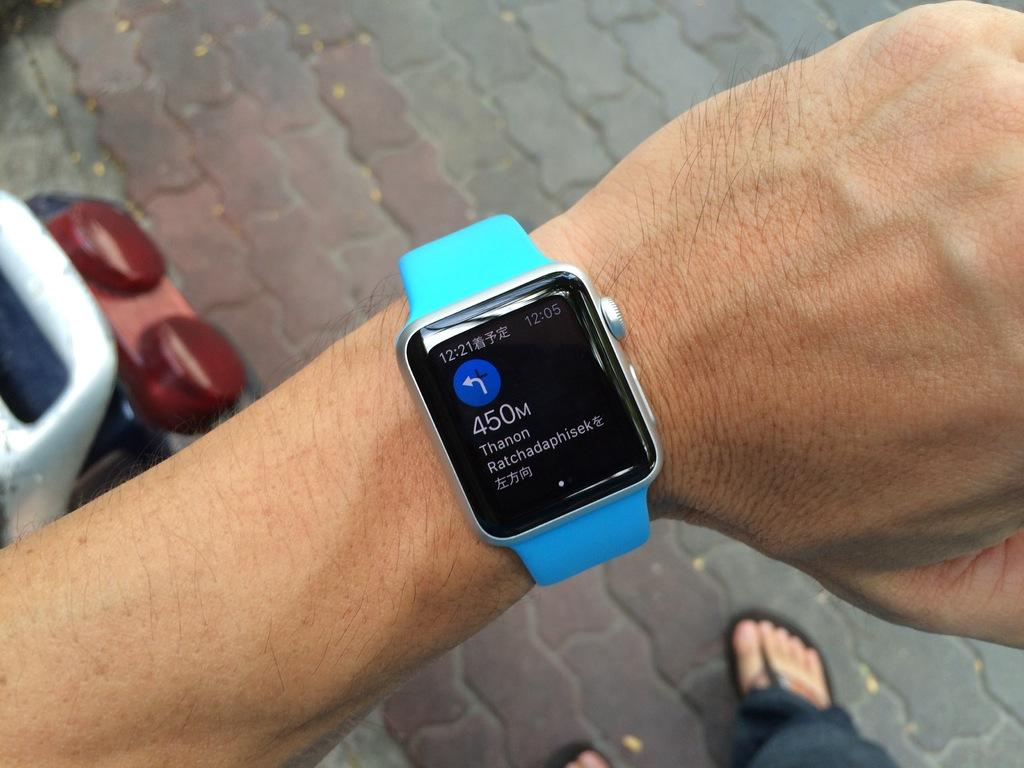<image>
Share a concise interpretation of the image provided. a smart watch with a black face on which is written 450 m 